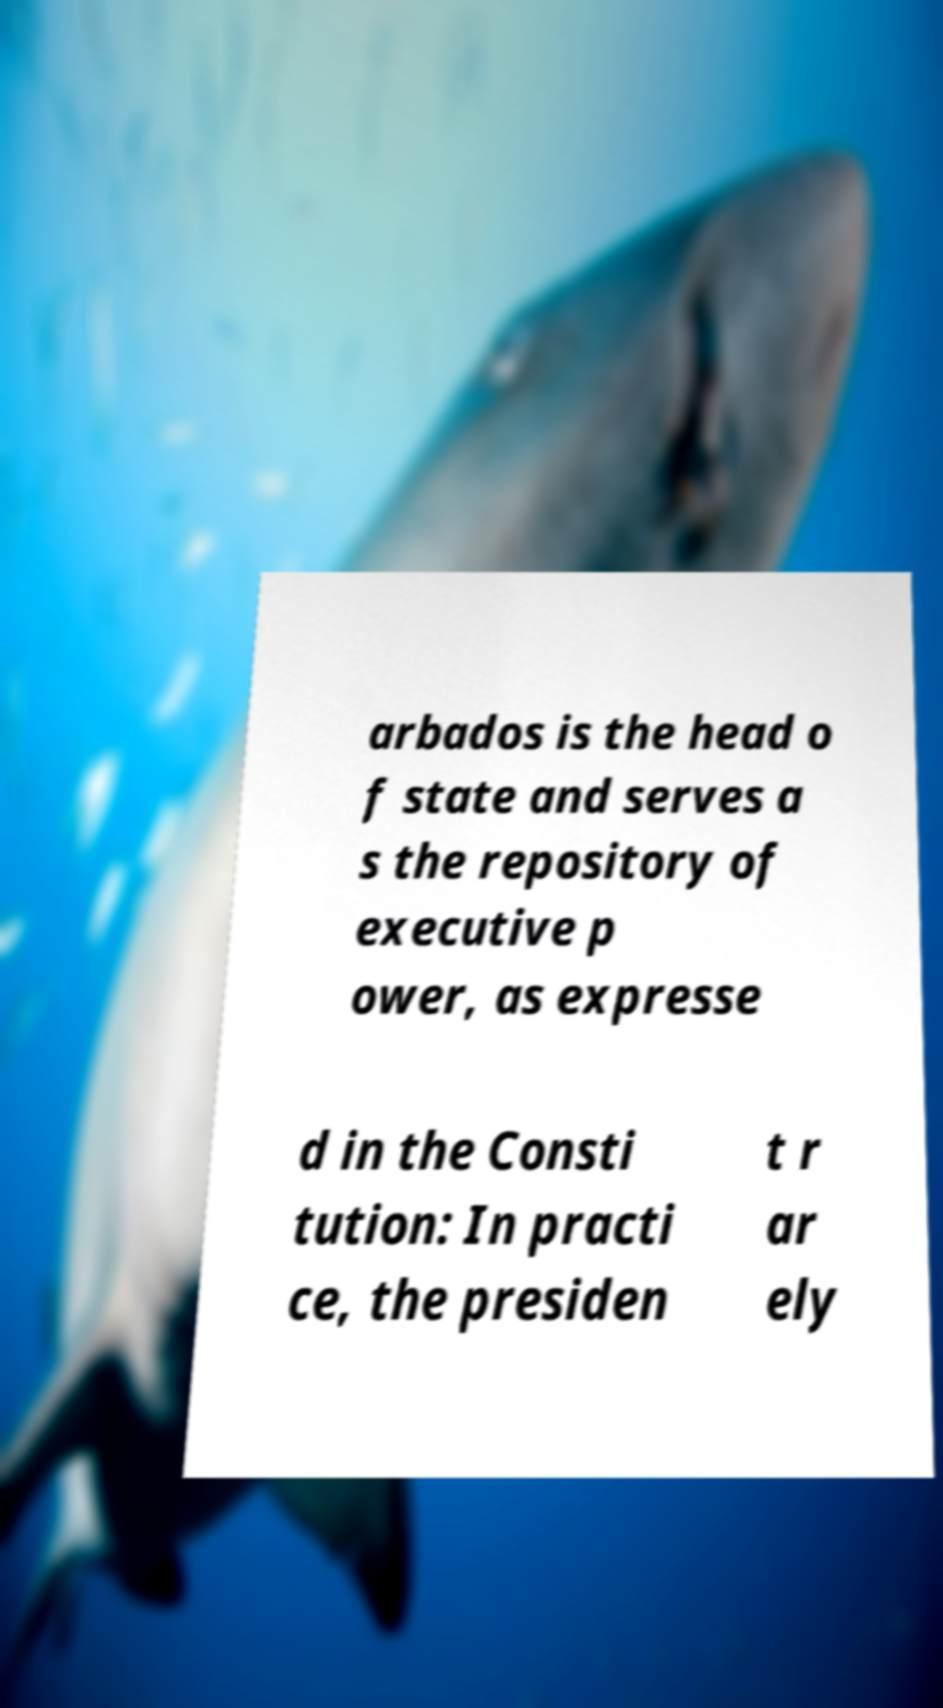There's text embedded in this image that I need extracted. Can you transcribe it verbatim? arbados is the head o f state and serves a s the repository of executive p ower, as expresse d in the Consti tution: In practi ce, the presiden t r ar ely 